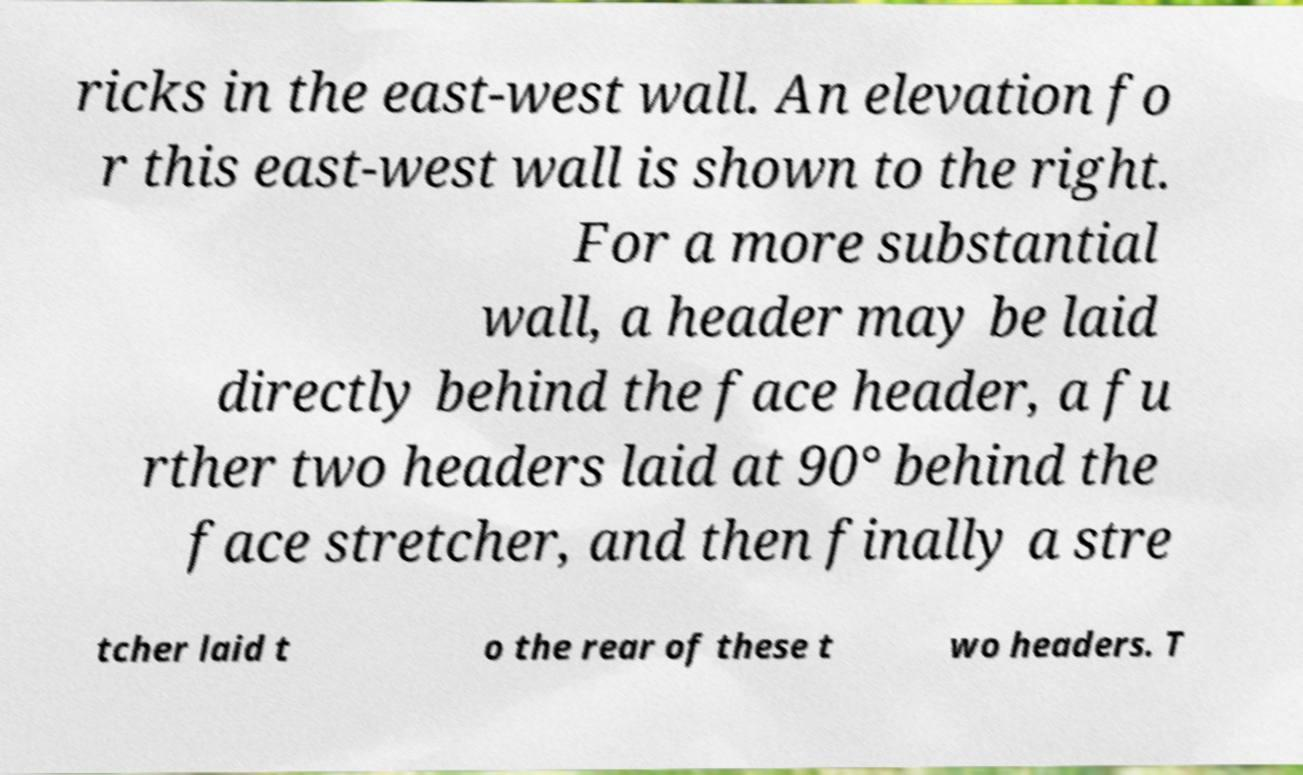Please read and relay the text visible in this image. What does it say? ricks in the east-west wall. An elevation fo r this east-west wall is shown to the right. For a more substantial wall, a header may be laid directly behind the face header, a fu rther two headers laid at 90° behind the face stretcher, and then finally a stre tcher laid t o the rear of these t wo headers. T 